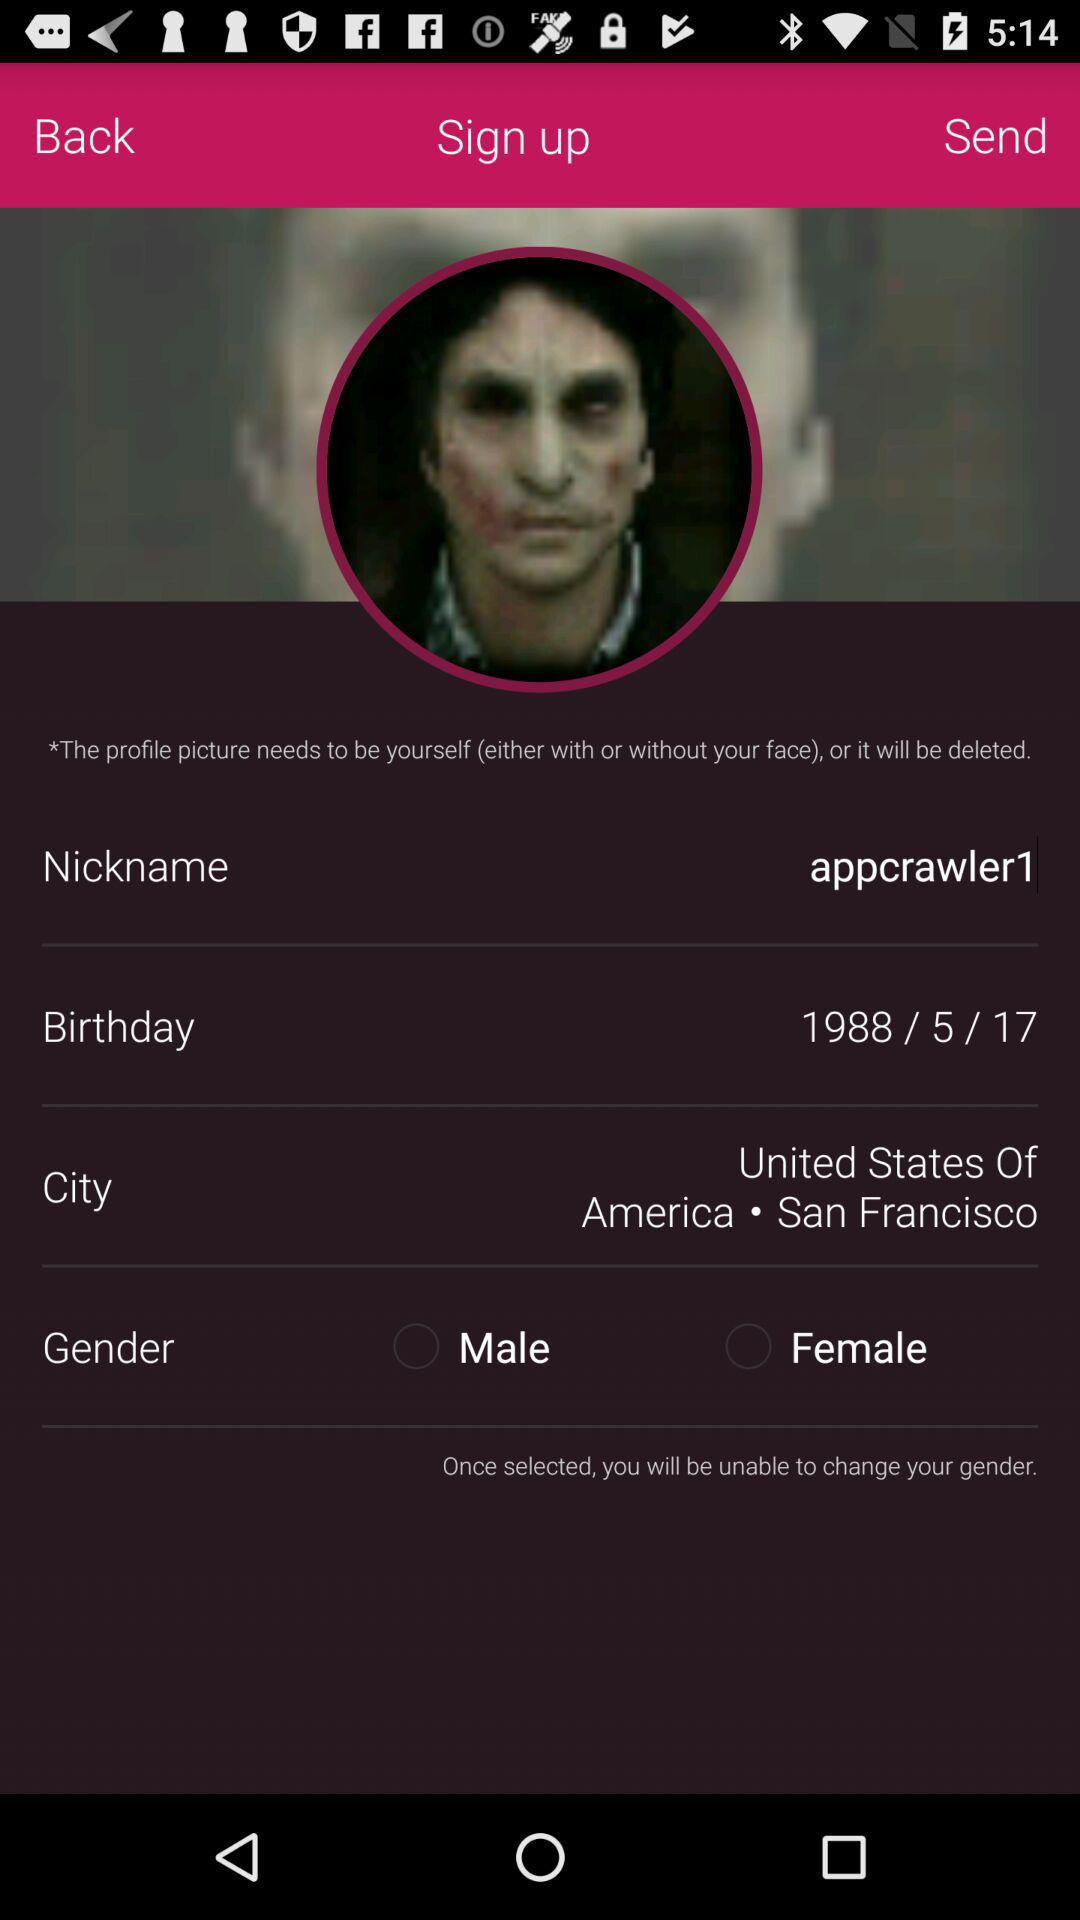What is the birth date? The birth date is May 17, 1988. 